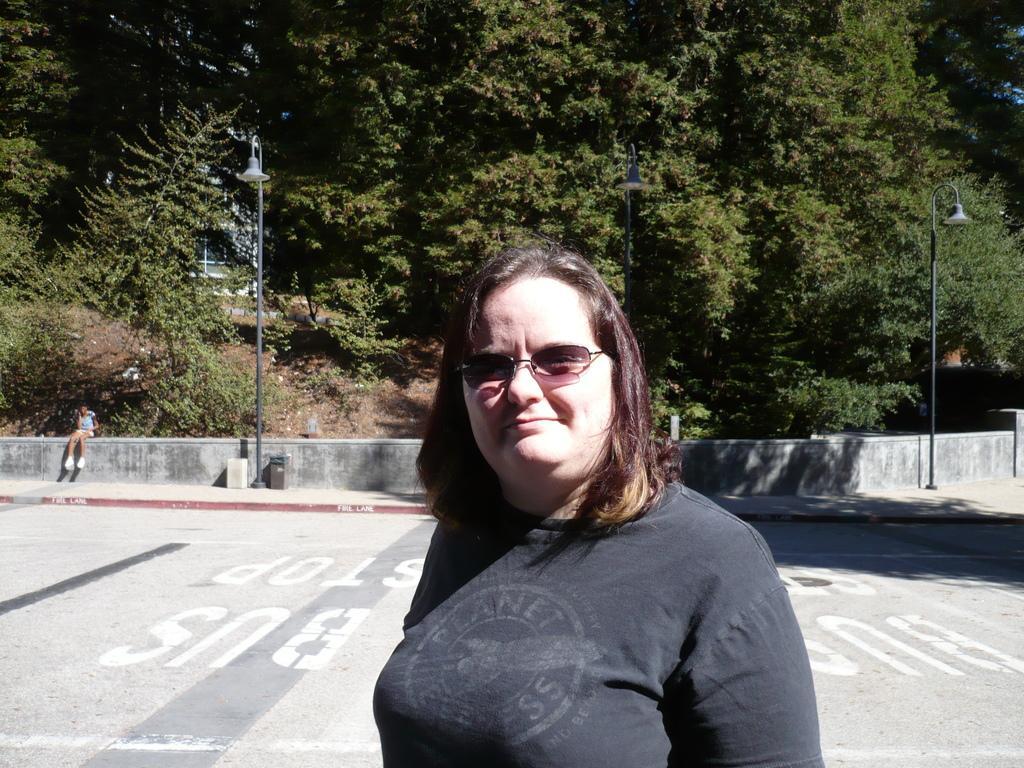Could you give a brief overview of what you see in this image? In this image I can see a woman at the bottom and a woman wearing a spectacle, at the top I can see trees , in the middle I can see the wall ,in front of the wall I can see street light poles and I can see a person sitting on the wall 